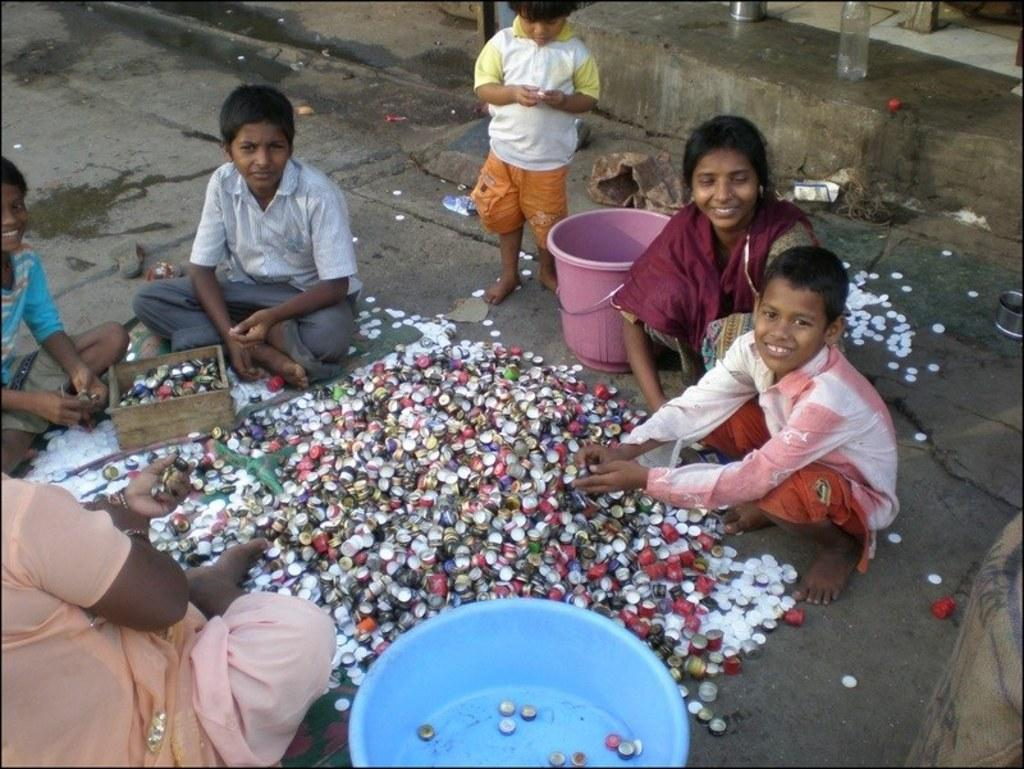How many people are in the image? There is a group of people in the image, but the exact number cannot be determined from the provided facts. What objects are present in the image besides the people? Bottle caps, a bowl, and a bucket are visible in the image. Is there any container for liquids in the image? Yes, there is a bottle in the background of the image. How many knots are tied in the net in the image? There is no net present in the image, and therefore no knots can be observed. What type of stitch is used to create the pattern on the bucket in the image? There is no mention of a pattern or stitching on the bucket in the image. 